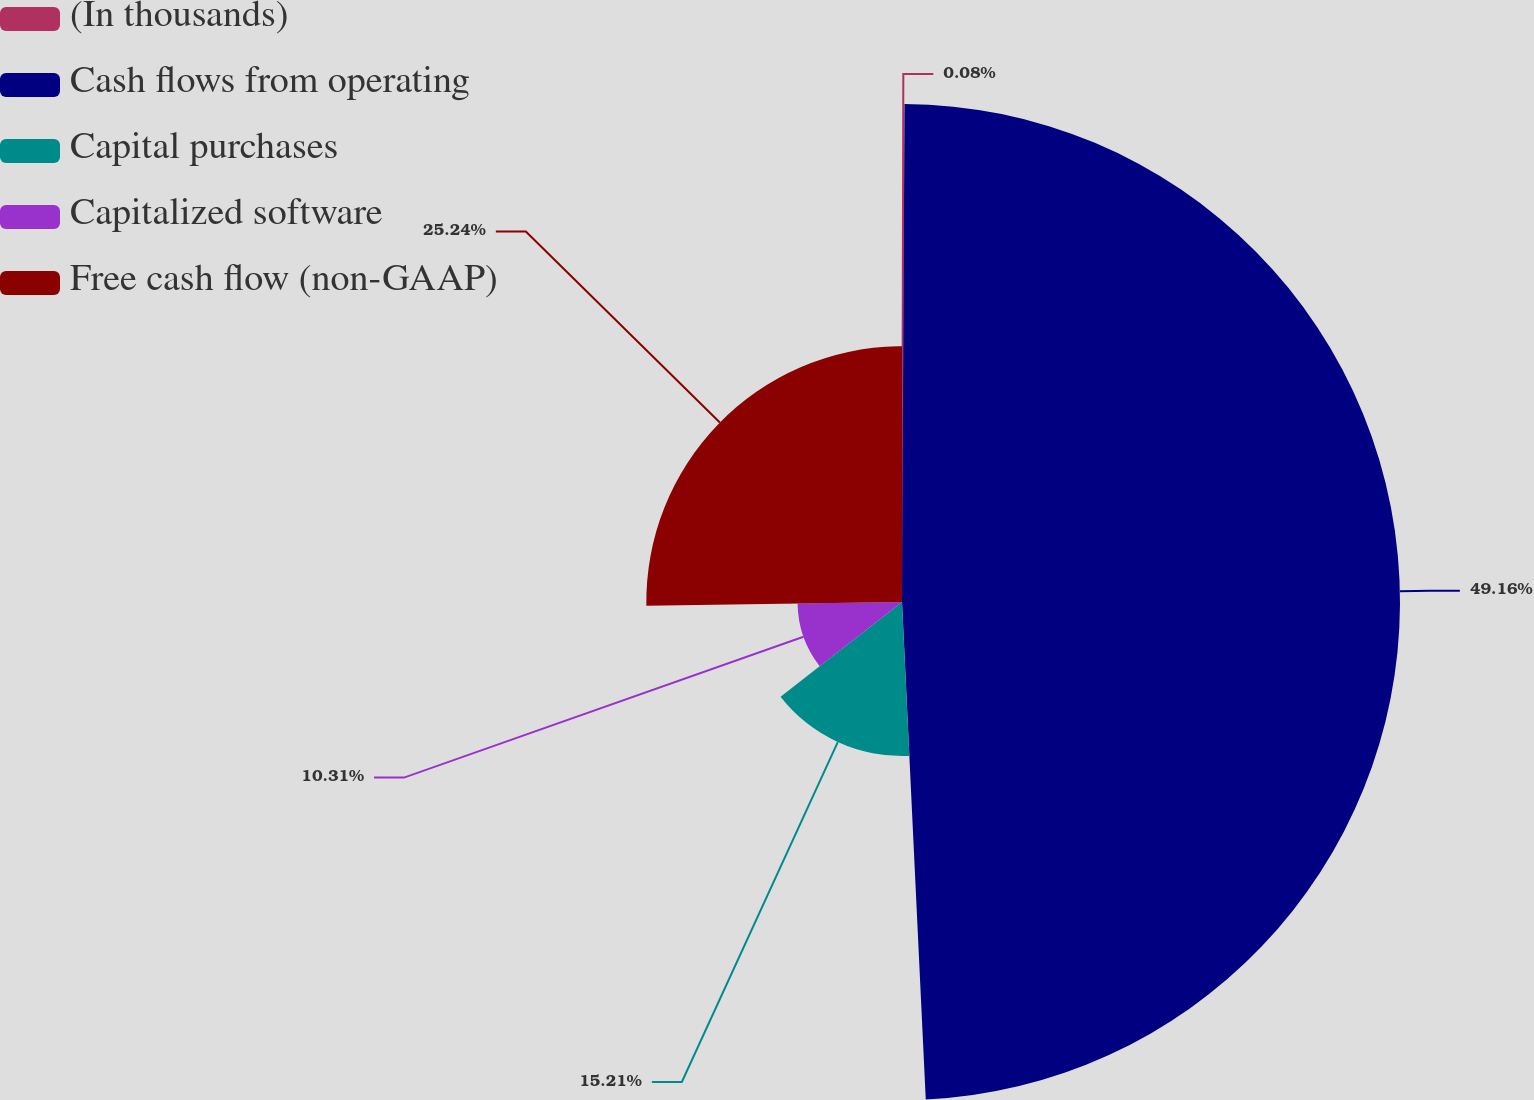Convert chart. <chart><loc_0><loc_0><loc_500><loc_500><pie_chart><fcel>(In thousands)<fcel>Cash flows from operating<fcel>Capital purchases<fcel>Capitalized software<fcel>Free cash flow (non-GAAP)<nl><fcel>0.08%<fcel>49.16%<fcel>15.21%<fcel>10.31%<fcel>25.24%<nl></chart> 